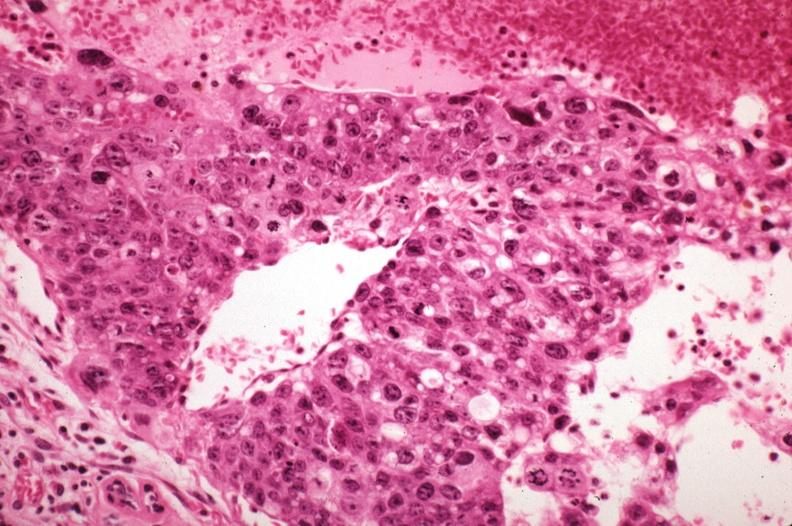does case of peritonitis slide show metastatic choriocarcinoma with pleomorphism?
Answer the question using a single word or phrase. No 